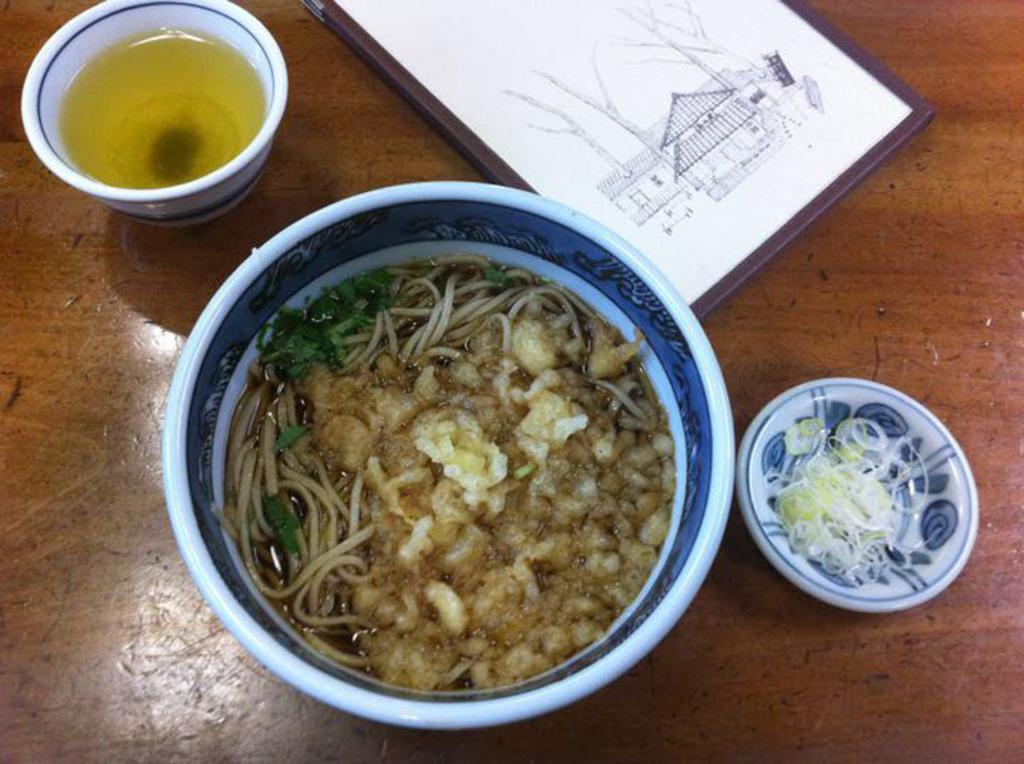In one or two sentences, can you explain what this image depicts? Bottom of the image there is a table, on the table there is a bowl, cup, saucer and frame and food. 